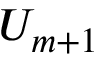Convert formula to latex. <formula><loc_0><loc_0><loc_500><loc_500>U _ { m + 1 }</formula> 